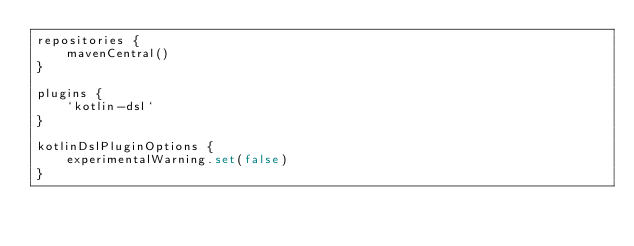<code> <loc_0><loc_0><loc_500><loc_500><_Kotlin_>repositories {
    mavenCentral()
}

plugins {
    `kotlin-dsl`
}

kotlinDslPluginOptions {
    experimentalWarning.set(false)
}
</code> 